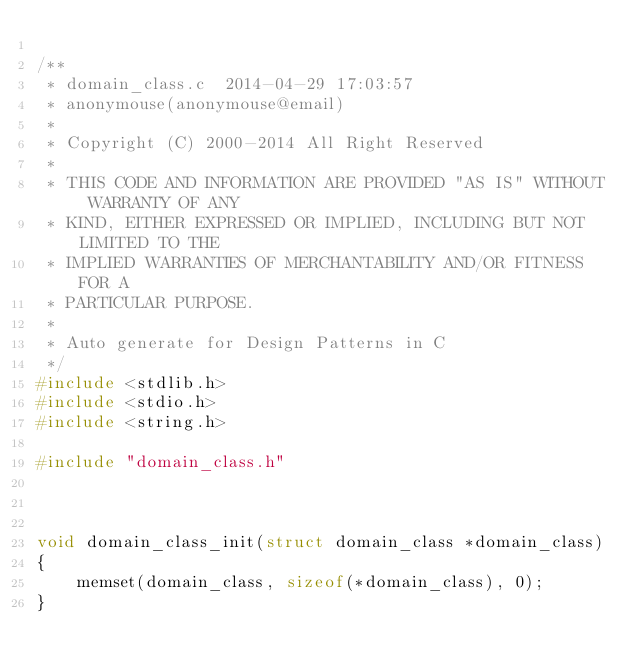Convert code to text. <code><loc_0><loc_0><loc_500><loc_500><_C_>
/**
 * domain_class.c  2014-04-29 17:03:57
 * anonymouse(anonymouse@email)
 *
 * Copyright (C) 2000-2014 All Right Reserved
 * 
 * THIS CODE AND INFORMATION ARE PROVIDED "AS IS" WITHOUT WARRANTY OF ANY
 * KIND, EITHER EXPRESSED OR IMPLIED, INCLUDING BUT NOT LIMITED TO THE
 * IMPLIED WARRANTIES OF MERCHANTABILITY AND/OR FITNESS FOR A
 * PARTICULAR PURPOSE.
 *
 * Auto generate for Design Patterns in C
 */
#include <stdlib.h>
#include <stdio.h>
#include <string.h>

#include "domain_class.h"



void domain_class_init(struct domain_class *domain_class)
{
	memset(domain_class, sizeof(*domain_class), 0);
}

</code> 